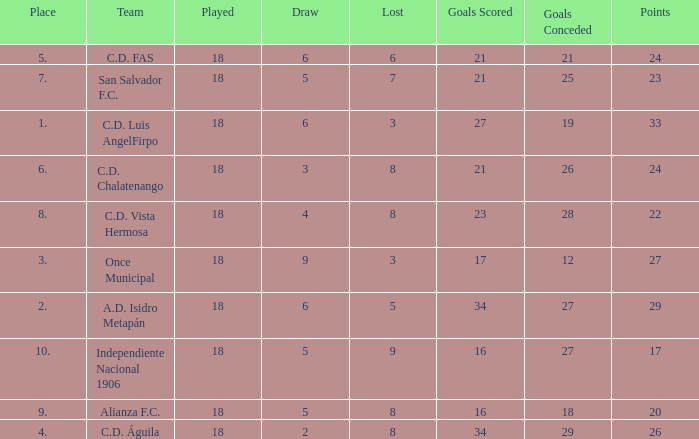What are the number of goals conceded that has a played greater than 18? 0.0. 